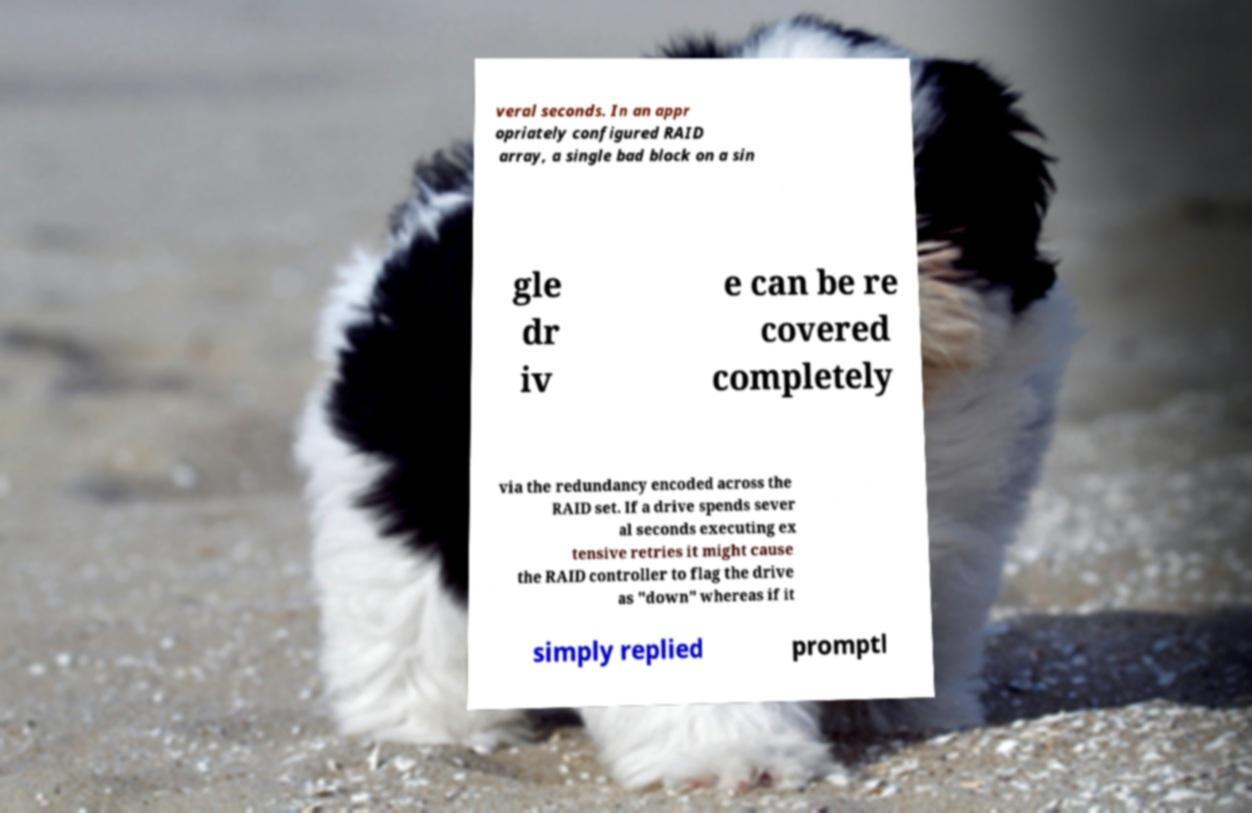Could you extract and type out the text from this image? veral seconds. In an appr opriately configured RAID array, a single bad block on a sin gle dr iv e can be re covered completely via the redundancy encoded across the RAID set. If a drive spends sever al seconds executing ex tensive retries it might cause the RAID controller to flag the drive as "down" whereas if it simply replied promptl 